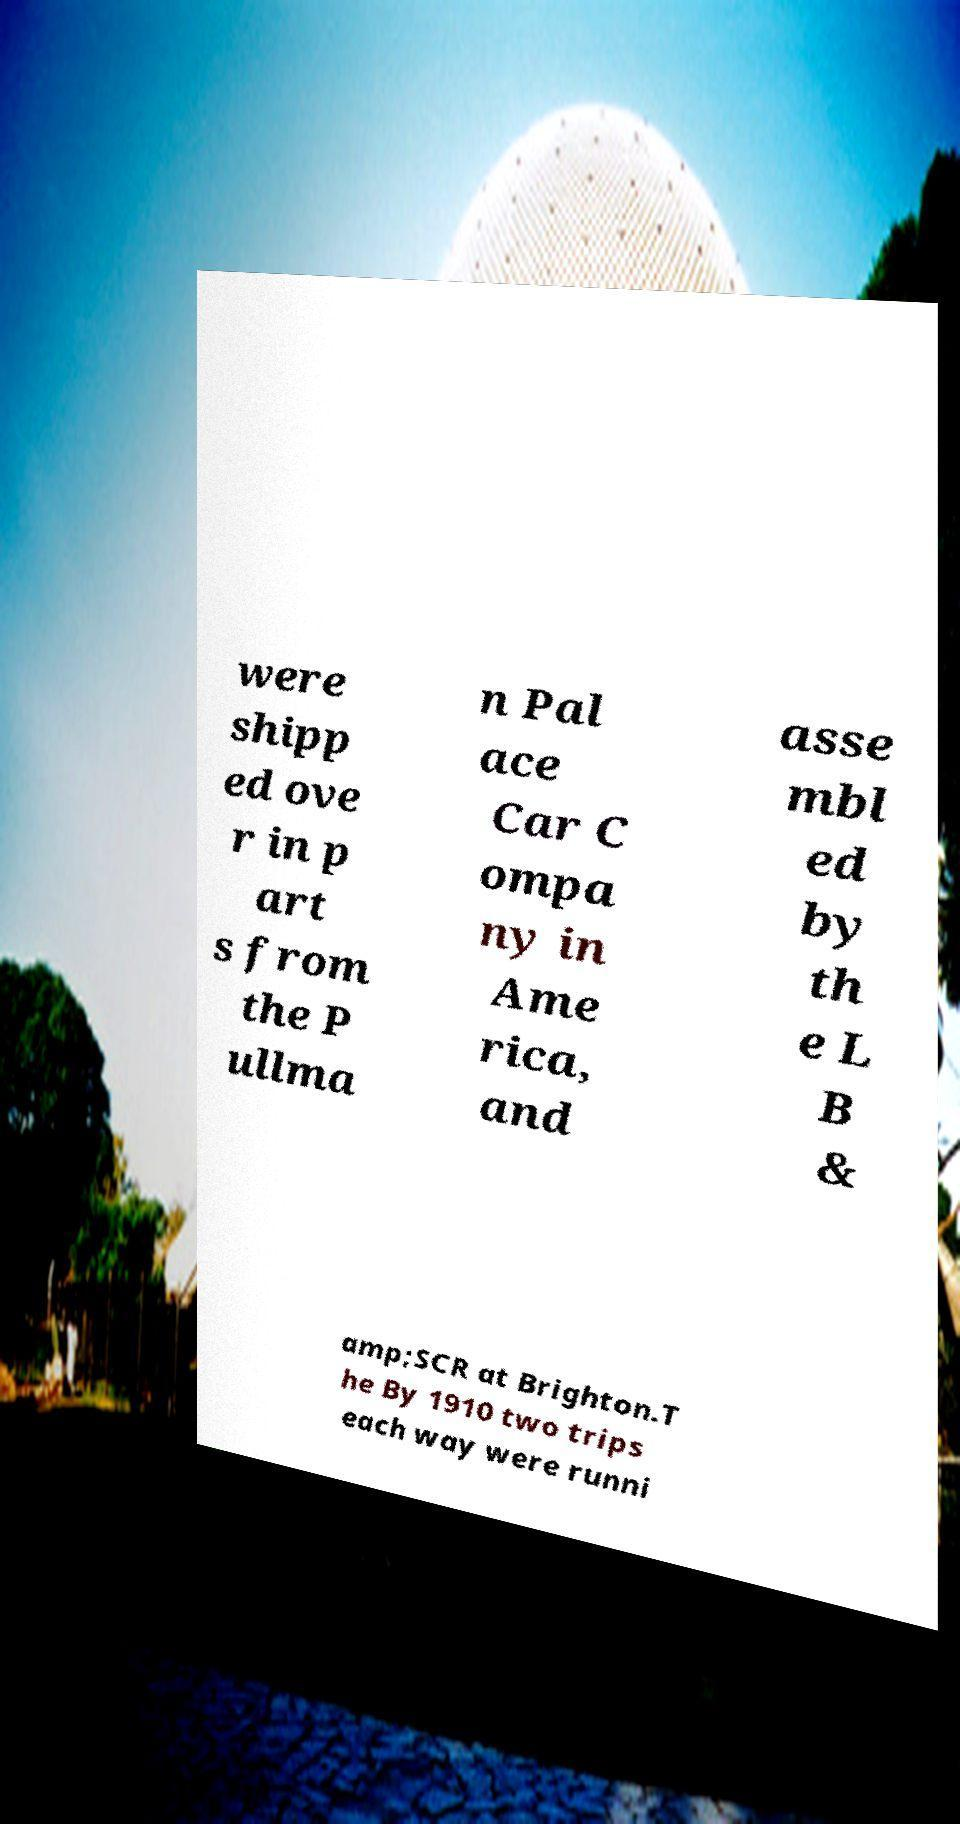What messages or text are displayed in this image? I need them in a readable, typed format. were shipp ed ove r in p art s from the P ullma n Pal ace Car C ompa ny in Ame rica, and asse mbl ed by th e L B & amp;SCR at Brighton.T he By 1910 two trips each way were runni 